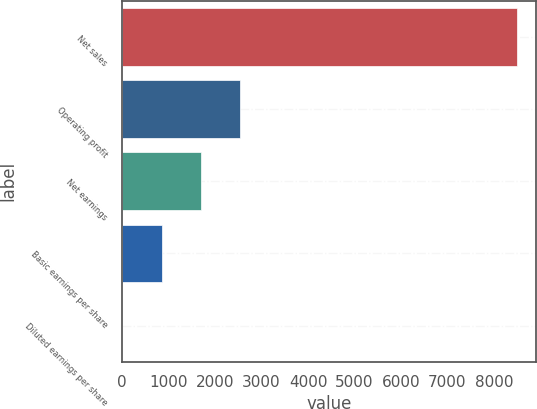<chart> <loc_0><loc_0><loc_500><loc_500><bar_chart><fcel>Net sales<fcel>Operating profit<fcel>Net earnings<fcel>Basic earnings per share<fcel>Diluted earnings per share<nl><fcel>8488<fcel>2546.99<fcel>1698.27<fcel>849.55<fcel>0.83<nl></chart> 